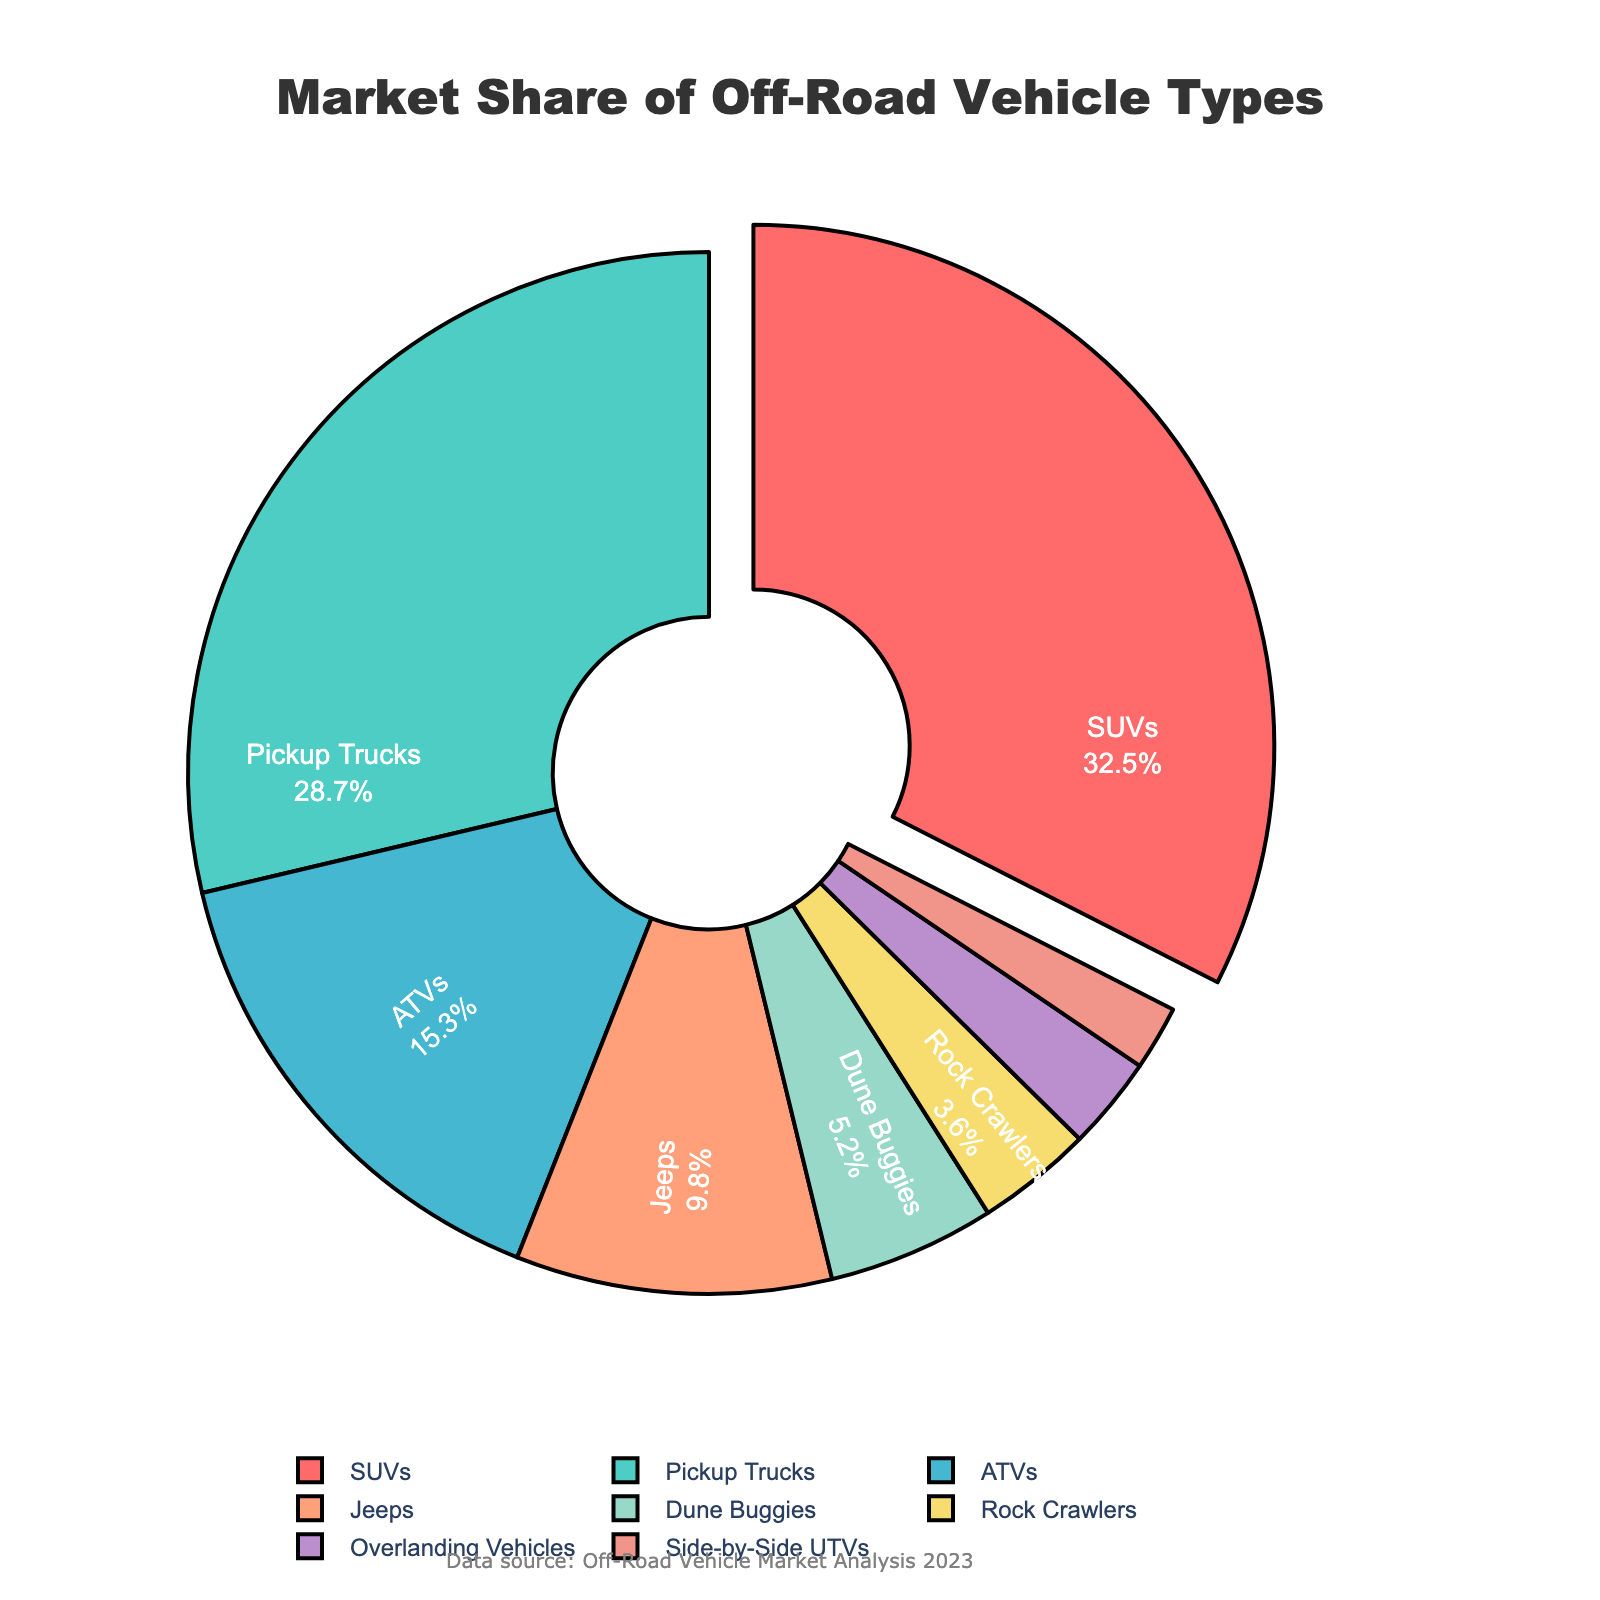What's the vehicle type with the highest market share? The pie chart shows segments with various market shares, and the largest segment corresponds to SUVs.
Answer: SUVs What is the combined market share of ATVs and Jeeps? The market share of ATVs is 15.3% and for Jeeps, it is 9.8%. Adding them together results in 15.3 + 9.8 = 25.1%.
Answer: 25.1% Which vehicle type has a slightly larger market share, pickup trucks or SUVs? Observing the pie chart, SUVs have a market share of 32.5%, whereas pickup trucks have 28.7%. SUVs have a slightly larger market share.
Answer: SUVs What is the difference in market share between Dune Buggies and Rock Crawlers? The market share of Dune Buggies is 5.2% and for Rock Crawlers, it is 3.6%. The difference is 5.2 - 3.6 = 1.6%.
Answer: 1.6% What percentage of the market is not represented by SUVs, Jeeps, and Overlanding Vehicles? The market share of SUVs is 32.5%, Jeeps 9.8%, and Overlanding Vehicles 2.9%. The combined market share is 32.5 + 9.8 + 2.9 = 45.2%. Subtracting from 100%, the market share not represented by these types is 100 - 45.2 = 54.8%.
Answer: 54.8% Which vehicle type has the least market share and what is the percentage? The pie chart shows that Side-by-Side UTVs have the smallest segment, corresponding to a 2.0% market share.
Answer: Side-by-Side UTVs, 2.0% By how much does the market share of SUVs exceed the market share of ATVs? The market share of SUVs is 32.5% and that of ATVs is 15.3%. The difference is 32.5 - 15.3 = 17.2%.
Answer: 17.2% Identify the vehicle type represented by a segment pulled out of the pie chart, and what is its market share? The segment pulled out of the pie chart represents SUVs, which have a market share of 32.5%.
Answer: SUVs, 32.5% Which color represents pickup trucks, according to the visual attributes? The pie chart uses color coding, and pickup trucks are represented by a light green segment.
Answer: Light green What is the combined market share of vehicle types that have less than 10% market share individually? The vehicle types with less than 10% market share are Jeeps (9.8%), Dune Buggies (5.2%), Rock Crawlers (3.6%), Overlanding Vehicles (2.9%), and Side-by-Side UTVs (2.0%). Together, their market share is 9.8 + 5.2 + 3.6 + 2.9 + 2.0 = 23.5%.
Answer: 23.5% 